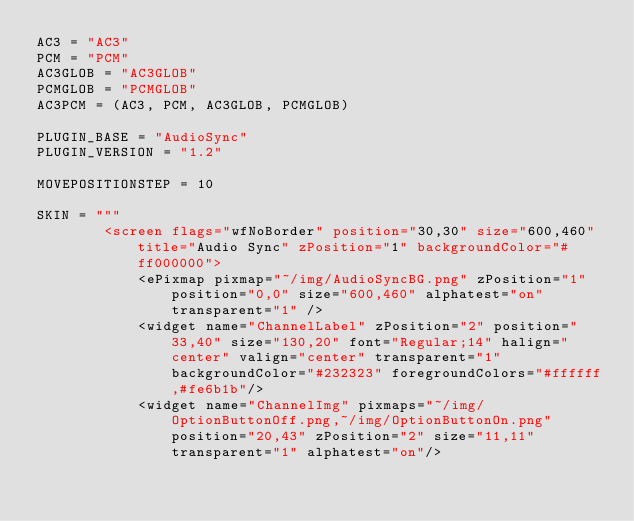Convert code to text. <code><loc_0><loc_0><loc_500><loc_500><_Python_>AC3 = "AC3"
PCM = "PCM"
AC3GLOB = "AC3GLOB"
PCMGLOB = "PCMGLOB"
AC3PCM = (AC3, PCM, AC3GLOB, PCMGLOB)

PLUGIN_BASE = "AudioSync"
PLUGIN_VERSION = "1.2"

MOVEPOSITIONSTEP = 10

SKIN = """
        <screen flags="wfNoBorder" position="30,30" size="600,460" title="Audio Sync" zPosition="1" backgroundColor="#ff000000">
            <ePixmap pixmap="~/img/AudioSyncBG.png" zPosition="1" position="0,0" size="600,460" alphatest="on" transparent="1" />
            <widget name="ChannelLabel" zPosition="2" position="33,40" size="130,20" font="Regular;14" halign="center" valign="center" transparent="1" backgroundColor="#232323" foregroundColors="#ffffff,#fe6b1b"/>
            <widget name="ChannelImg" pixmaps="~/img/OptionButtonOff.png,~/img/OptionButtonOn.png" position="20,43" zPosition="2" size="11,11" transparent="1" alphatest="on"/></code> 